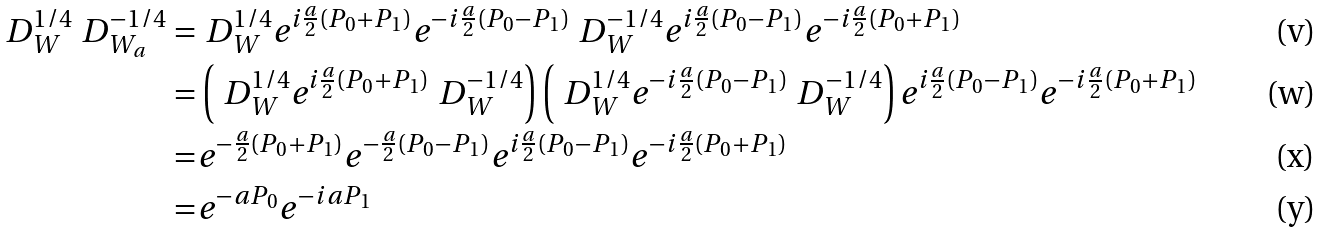<formula> <loc_0><loc_0><loc_500><loc_500>\ D _ { W } ^ { 1 / 4 } \ D _ { W _ { a } } ^ { - 1 / 4 } = & \ D _ { W } ^ { 1 / 4 } e ^ { i \frac { a } { 2 } ( P _ { 0 } + P _ { 1 } ) } e ^ { - i \frac { a } { 2 } ( P _ { 0 } - P _ { 1 } ) } \ D _ { W } ^ { - 1 / 4 } e ^ { i \frac { a } { 2 } ( P _ { 0 } - P _ { 1 } ) } e ^ { - i \frac { a } { 2 } ( P _ { 0 } + P _ { 1 } ) } \\ = & \left ( \ D _ { W } ^ { 1 / 4 } e ^ { i \frac { a } { 2 } ( P _ { 0 } + P _ { 1 } ) } \ D _ { W } ^ { - 1 / 4 } \right ) \left ( \ D _ { W } ^ { 1 / 4 } e ^ { - i \frac { a } { 2 } ( P _ { 0 } - P _ { 1 } ) } \ D _ { W } ^ { - 1 / 4 } \right ) e ^ { i \frac { a } { 2 } ( P _ { 0 } - P _ { 1 } ) } e ^ { - i \frac { a } { 2 } ( P _ { 0 } + P _ { 1 } ) } \\ = & e ^ { - \frac { a } { 2 } ( P _ { 0 } + P _ { 1 } ) } e ^ { - \frac { a } { 2 } ( P _ { 0 } - P _ { 1 } ) } e ^ { i \frac { a } { 2 } ( P _ { 0 } - P _ { 1 } ) } e ^ { - i \frac { a } { 2 } ( P _ { 0 } + P _ { 1 } ) } \\ = & e ^ { - a P _ { 0 } } e ^ { - i a P _ { 1 } }</formula> 